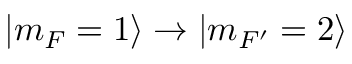<formula> <loc_0><loc_0><loc_500><loc_500>| m _ { F } = 1 \rangle \rightarrow | m _ { F ^ { \prime } } = 2 \rangle</formula> 